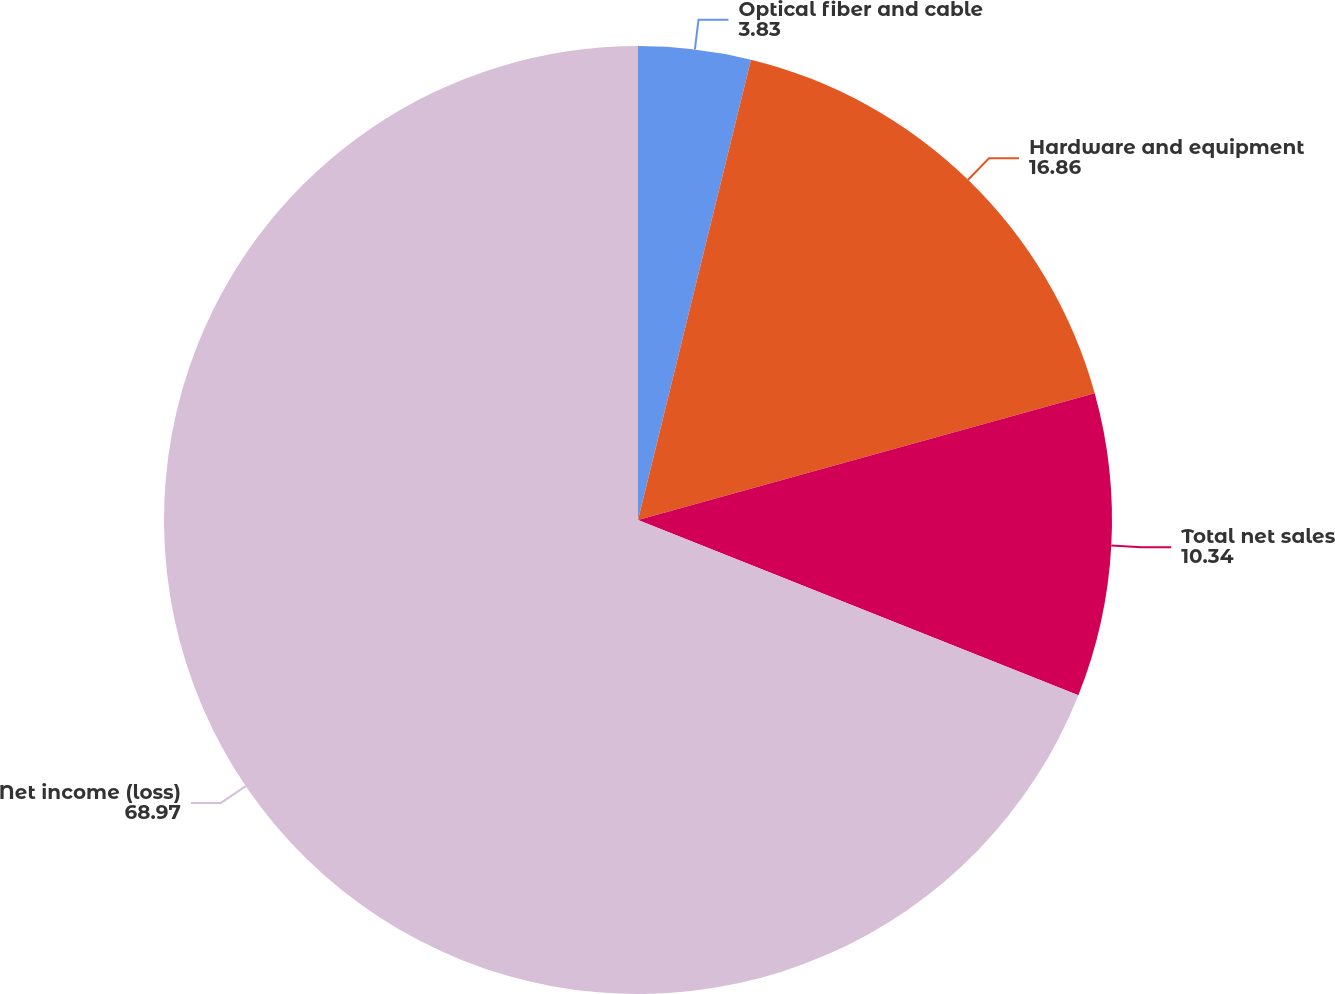<chart> <loc_0><loc_0><loc_500><loc_500><pie_chart><fcel>Optical fiber and cable<fcel>Hardware and equipment<fcel>Total net sales<fcel>Net income (loss)<nl><fcel>3.83%<fcel>16.86%<fcel>10.34%<fcel>68.97%<nl></chart> 